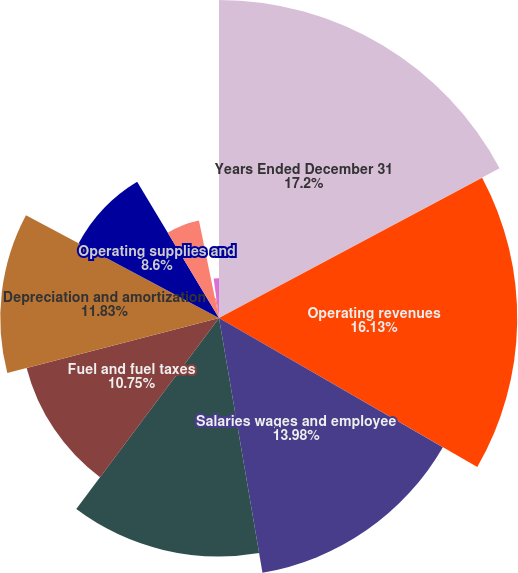Convert chart to OTSL. <chart><loc_0><loc_0><loc_500><loc_500><pie_chart><fcel>Years Ended December 31<fcel>Operating revenues<fcel>Salaries wages and employee<fcel>Rents and purchased<fcel>Fuel and fuel taxes<fcel>Depreciation and amortization<fcel>Operating supplies and<fcel>Insurance and claims<fcel>Operating taxes and licenses<fcel>General and administrative<nl><fcel>17.2%<fcel>16.13%<fcel>13.98%<fcel>12.9%<fcel>10.75%<fcel>11.83%<fcel>8.6%<fcel>5.38%<fcel>1.08%<fcel>2.15%<nl></chart> 